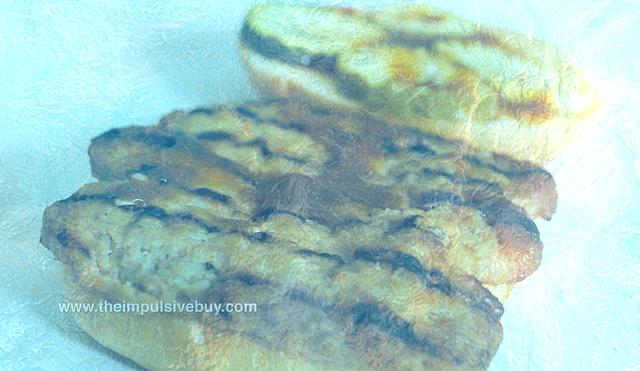What object is recognizable as the subject of the image?
A. A cup of coffee on the side.
B. A slice of pizza at the bottom.
C. A loaf of bread in the middle. The subject of the image is a loaf of bread positioned in the center, exhibiting a golden-brown crust, which is characteristic of a well-baked loaf. It is the primary focus of the image and there are no other food items, such as a cup of coffee or a slice of pizza, present. 